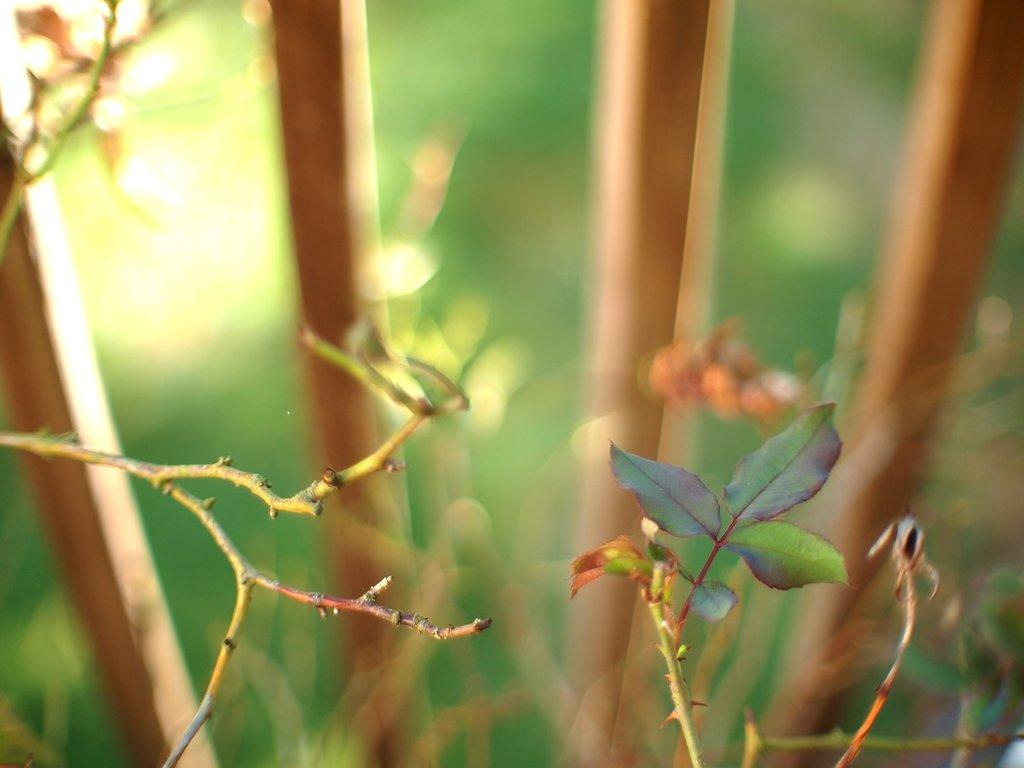What can be seen in the foreground of the image? There are leaves in the foreground of the image. What is visible in the background of the image? There are sticks and plants in the background of the image. What type of quartz can be seen in the image? There is no quartz present in the image. What afterthought or observation can be made about the image? The provided facts do not suggest any specific afterthought or observation, as the conversation focuses on the direct description of the image's contents. 